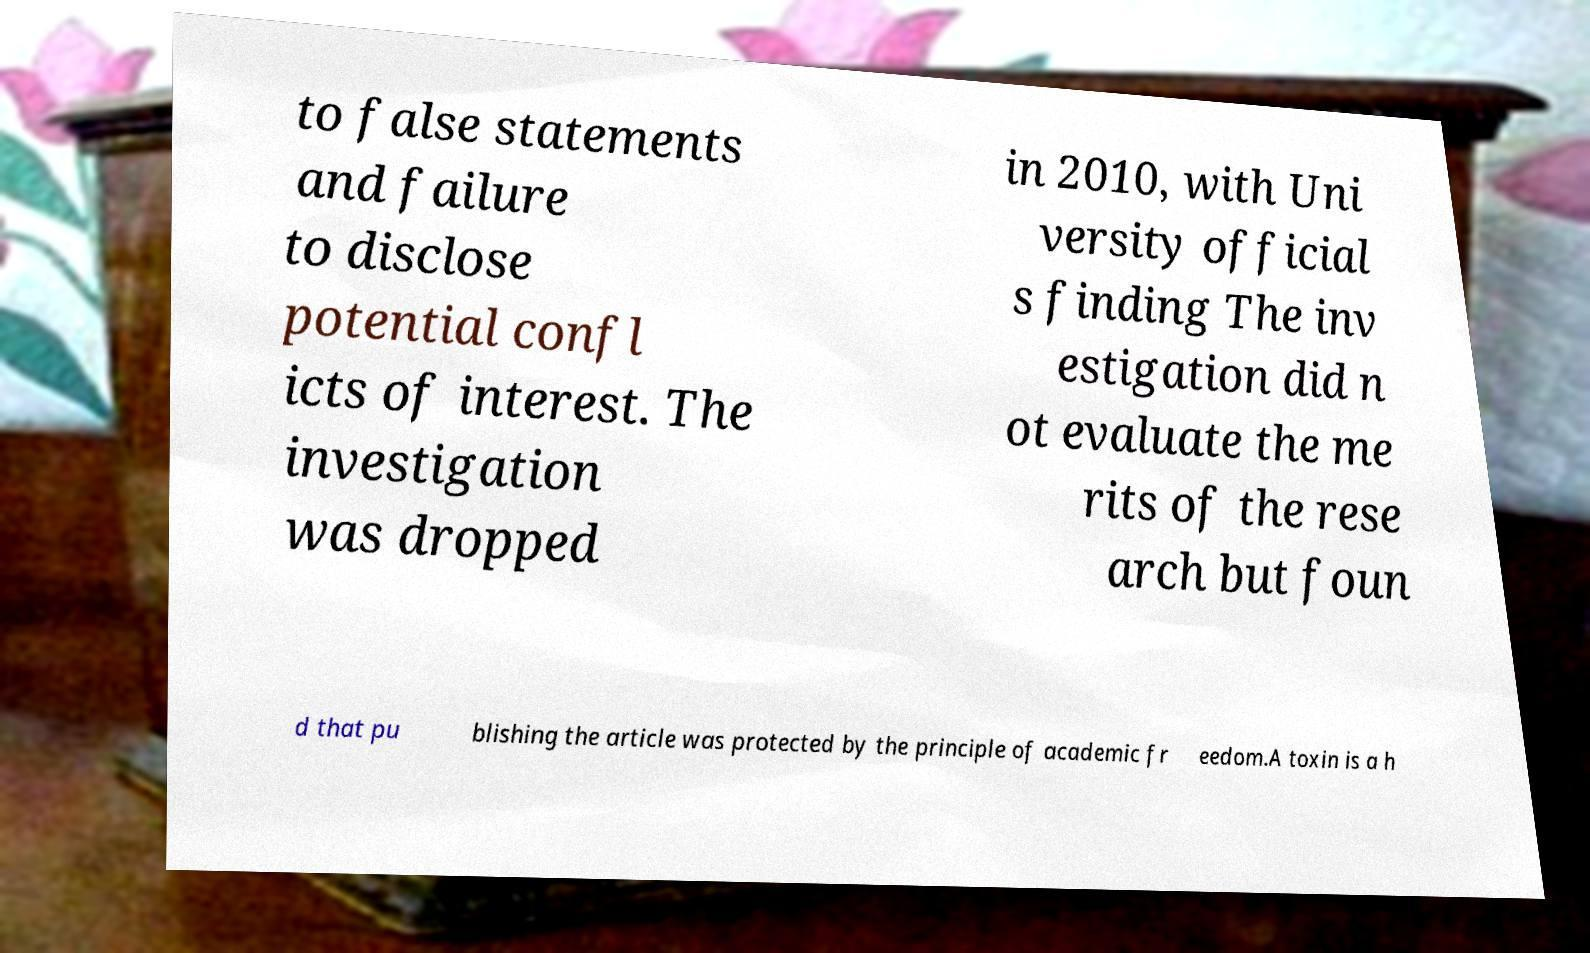Please identify and transcribe the text found in this image. to false statements and failure to disclose potential confl icts of interest. The investigation was dropped in 2010, with Uni versity official s finding The inv estigation did n ot evaluate the me rits of the rese arch but foun d that pu blishing the article was protected by the principle of academic fr eedom.A toxin is a h 